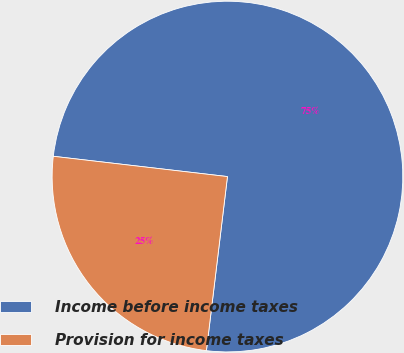Convert chart. <chart><loc_0><loc_0><loc_500><loc_500><pie_chart><fcel>Income before income taxes<fcel>Provision for income taxes<nl><fcel>75.07%<fcel>24.93%<nl></chart> 